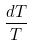Convert formula to latex. <formula><loc_0><loc_0><loc_500><loc_500>\frac { d T } { T }</formula> 